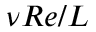<formula> <loc_0><loc_0><loc_500><loc_500>\nu R e / L</formula> 